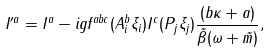<formula> <loc_0><loc_0><loc_500><loc_500>I ^ { \prime a } = I ^ { a } - i g f ^ { a b c } ( A _ { i } ^ { b } \xi _ { i } ) I ^ { c } ( P _ { j } \xi _ { j } ) \frac { ( b \kappa + a ) } { \tilde { \beta } ( \omega + \tilde { m } ) } ,</formula> 